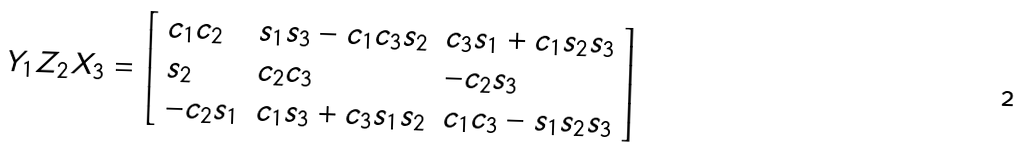Convert formula to latex. <formula><loc_0><loc_0><loc_500><loc_500>Y _ { 1 } Z _ { 2 } X _ { 3 } = { \left [ \begin{array} { l l l } { c _ { 1 } c _ { 2 } } & { s _ { 1 } s _ { 3 } - c _ { 1 } c _ { 3 } s _ { 2 } } & { c _ { 3 } s _ { 1 } + c _ { 1 } s _ { 2 } s _ { 3 } } \\ { s _ { 2 } } & { c _ { 2 } c _ { 3 } } & { - c _ { 2 } s _ { 3 } } \\ { - c _ { 2 } s _ { 1 } } & { c _ { 1 } s _ { 3 } + c _ { 3 } s _ { 1 } s _ { 2 } } & { c _ { 1 } c _ { 3 } - s _ { 1 } s _ { 2 } s _ { 3 } } \end{array} \right ] }</formula> 